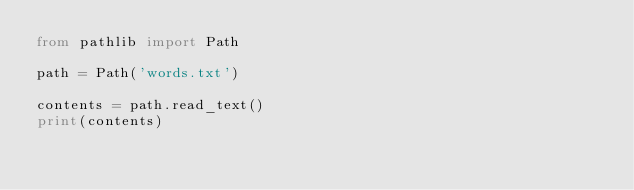Convert code to text. <code><loc_0><loc_0><loc_500><loc_500><_Python_>from pathlib import Path

path = Path('words.txt')

contents = path.read_text()
print(contents)</code> 